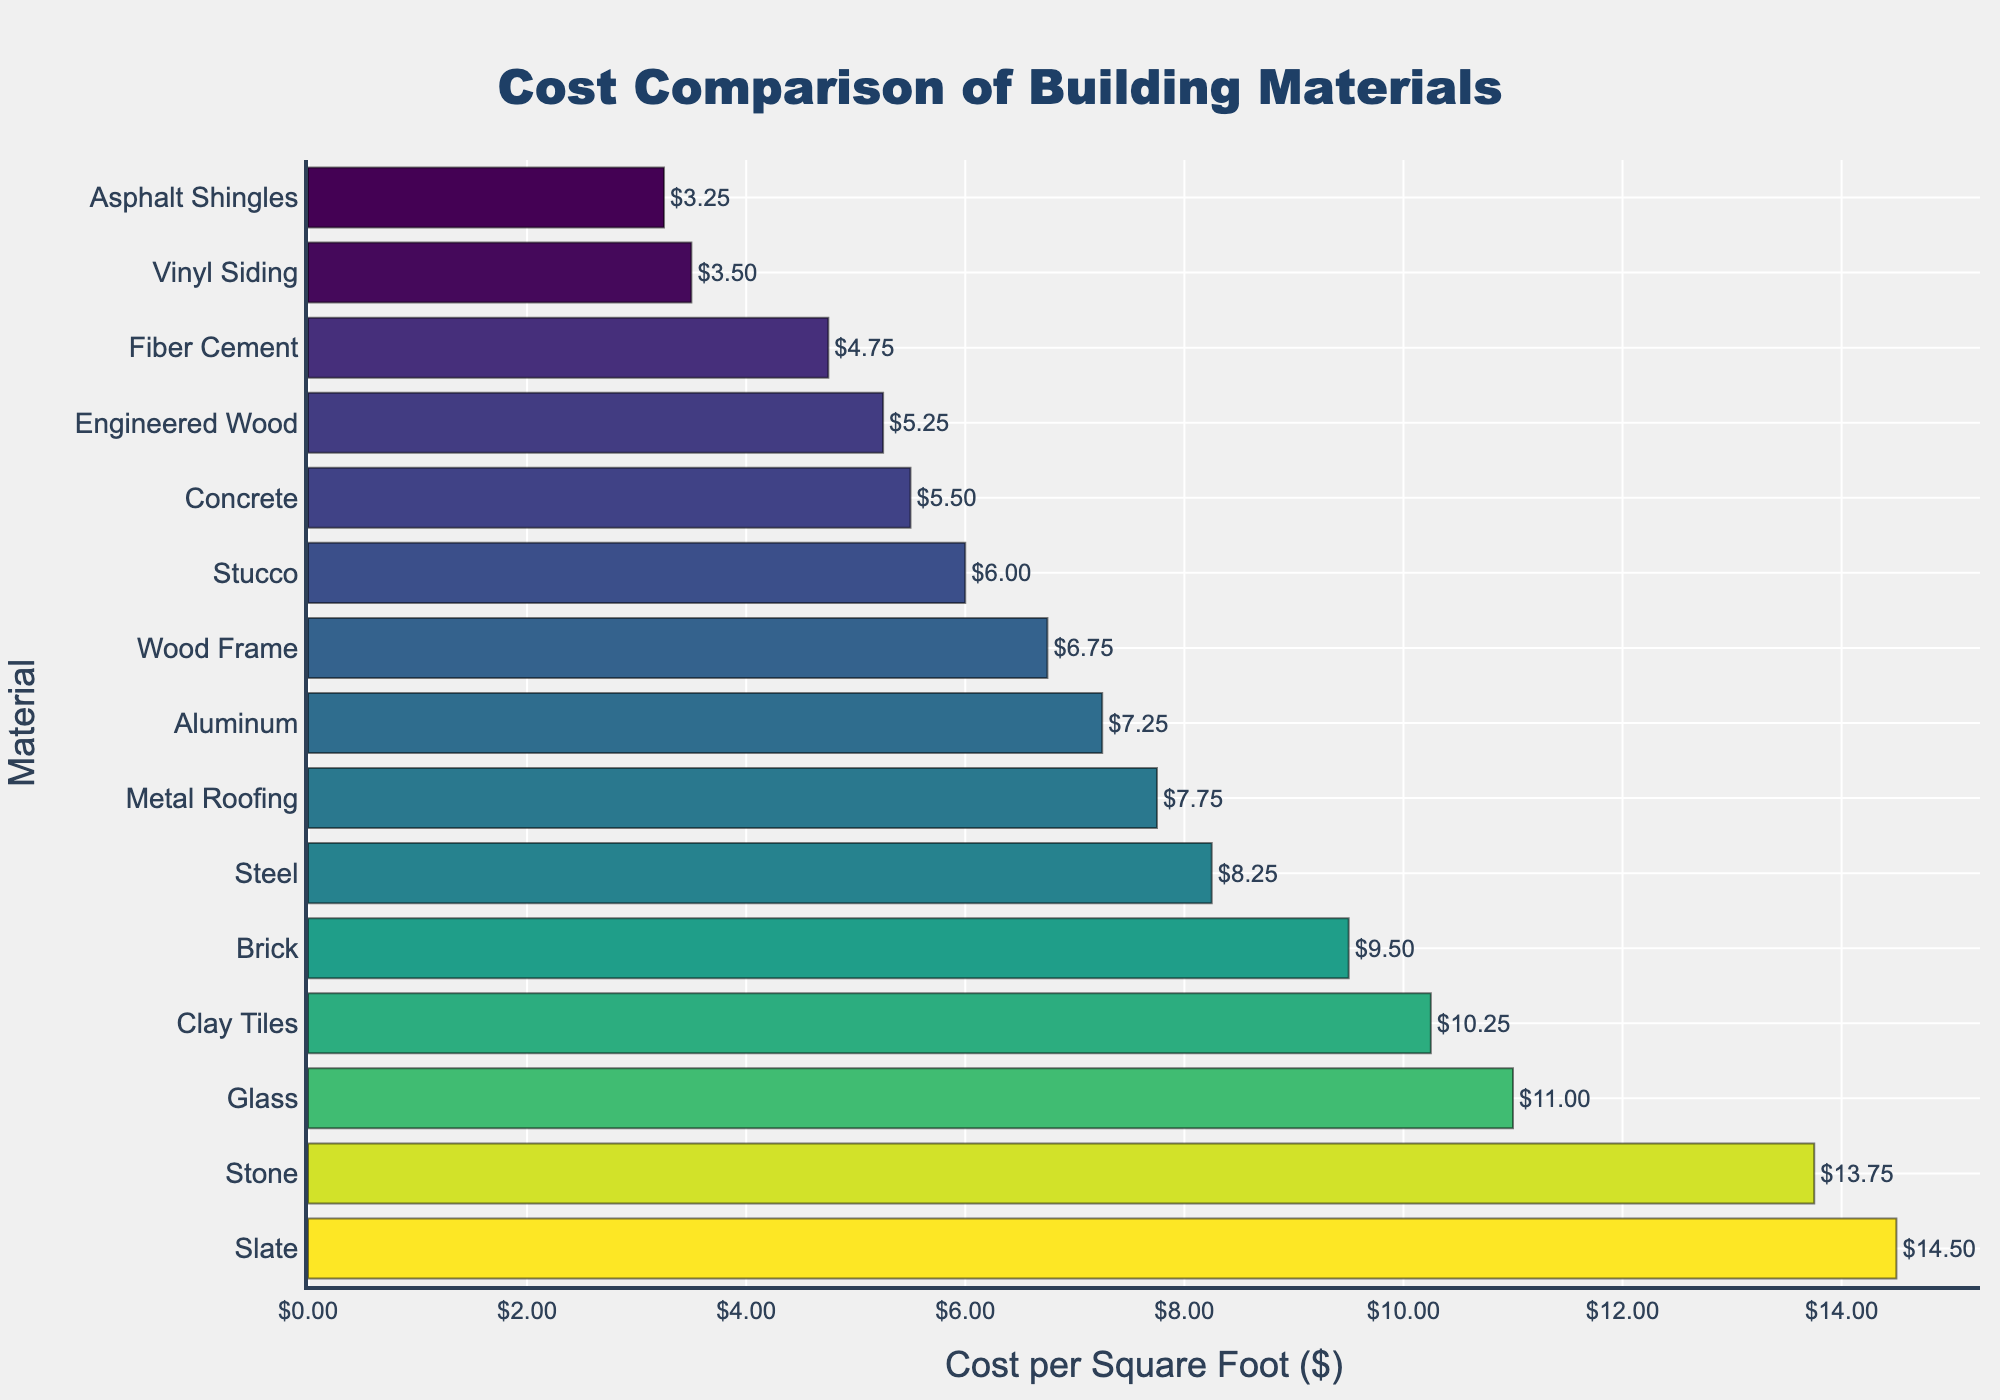What is the cost per square foot of the most expensive building material? The most expensive material is positioned at the top of the bar chart. Identify the longest bar, which represents Slate, with a cost of $14.50 per square foot.
Answer: $14.50 Which building material has the lowest cost per square foot? Look for the shortest bar at the bottom of the chart, representing Asphalt Shingles, with a cost of $3.25 per square foot.
Answer: Asphalt Shingles What is the cost difference between Steel and Aluminum? Locate the bars for Steel and Aluminum, then subtract Aluminum's cost from Steel's cost: $8.25 - $7.25.
Answer: $1.00 How much more expensive is Brick than Fiber Cement? Find Brick and Fiber Cement on the chart and subtract Fiber Cement's cost from Brick's cost: $9.50 - $4.75.
Answer: $4.75 Which materials cost between $10 and $12 per square foot? Identify the bars within the range of $10 to $12 per square foot, which are Glass and Clay Tiles.
Answer: Glass, Clay Tiles Is the cost of Wood Frame greater than the cost of Concrete? Compare the bars for Wood Frame and Concrete. Wood Frame costs $6.75 and Concrete costs $5.50, so Wood Frame is more expensive.
Answer: Yes What is the average cost per square foot of all the materials listed? Sum up the costs of all materials and divide by the number of materials: (5.50 + 6.75 + 8.25 + 9.50 + 11.00 + 13.75 + 7.25 + 4.75 + 6.00 + 3.50 + 5.25 + 7.75 + 3.25 + 14.50 + 10.25) / 15 = 96.25 / 15.
Answer: $6.42 How many materials cost more than $10 per square foot? Count the bars representing materials with costs higher than $10. There are four: Glass, Clay Tiles, Stone, and Slate.
Answer: 4 Which material has a cost closest to $7 per square foot? Identify the bar whose value is nearest to $7, which is Aluminum with a cost of $7.25 per square foot.
Answer: Aluminum What is the combined cost per square foot of Vinyl Siding and Engineered Wood? Add the costs of Vinyl Siding and Engineered Wood: $3.50 + $5.25.
Answer: $8.75 